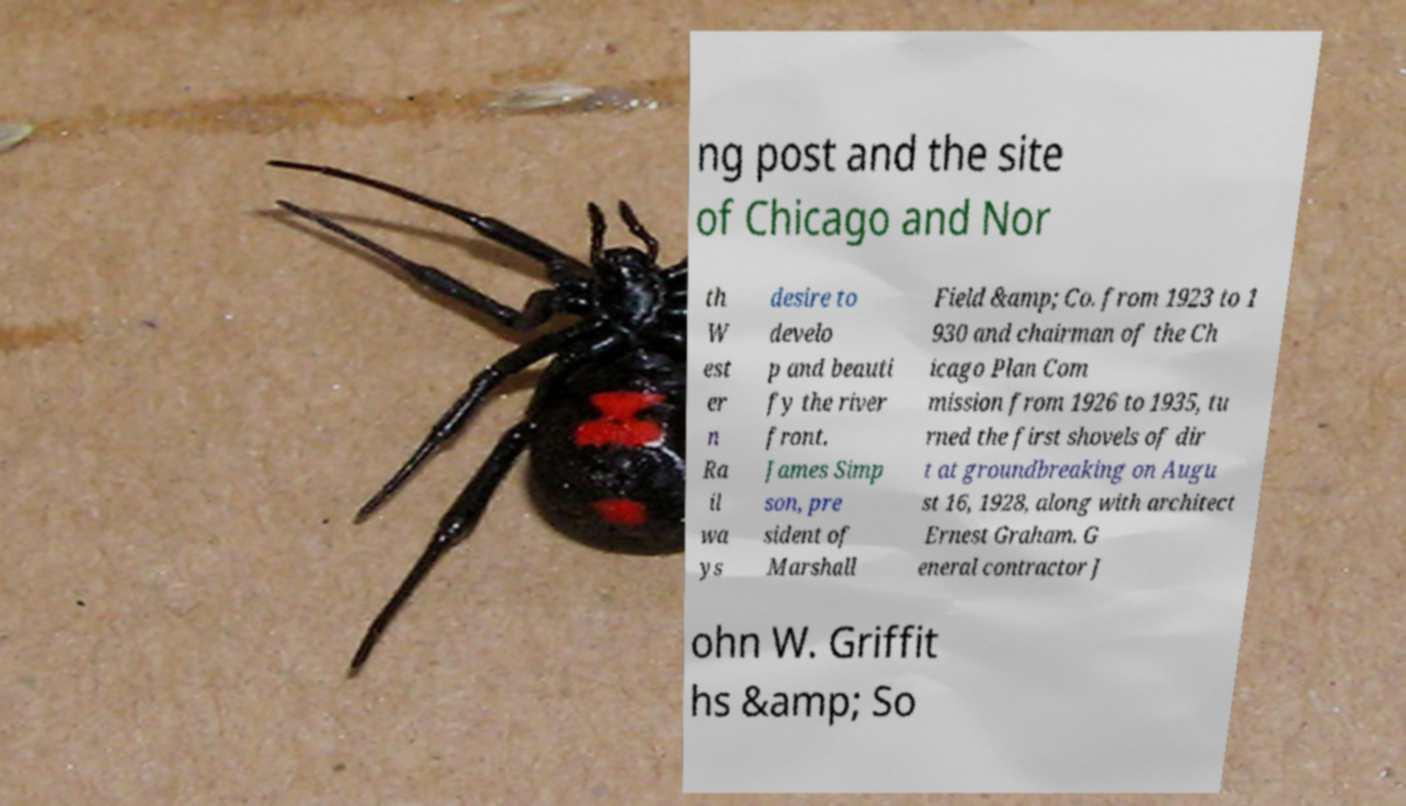What messages or text are displayed in this image? I need them in a readable, typed format. ng post and the site of Chicago and Nor th W est er n Ra il wa ys desire to develo p and beauti fy the river front. James Simp son, pre sident of Marshall Field &amp; Co. from 1923 to 1 930 and chairman of the Ch icago Plan Com mission from 1926 to 1935, tu rned the first shovels of dir t at groundbreaking on Augu st 16, 1928, along with architect Ernest Graham. G eneral contractor J ohn W. Griffit hs &amp; So 